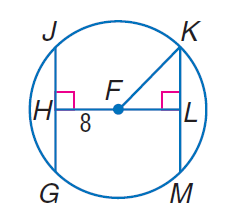Answer the mathemtical geometry problem and directly provide the correct option letter.
Question: In \odot F, F H \cong F L and F K = 17. Find L K.
Choices: A: 8 B: 15 C: 16 D: 17 B 